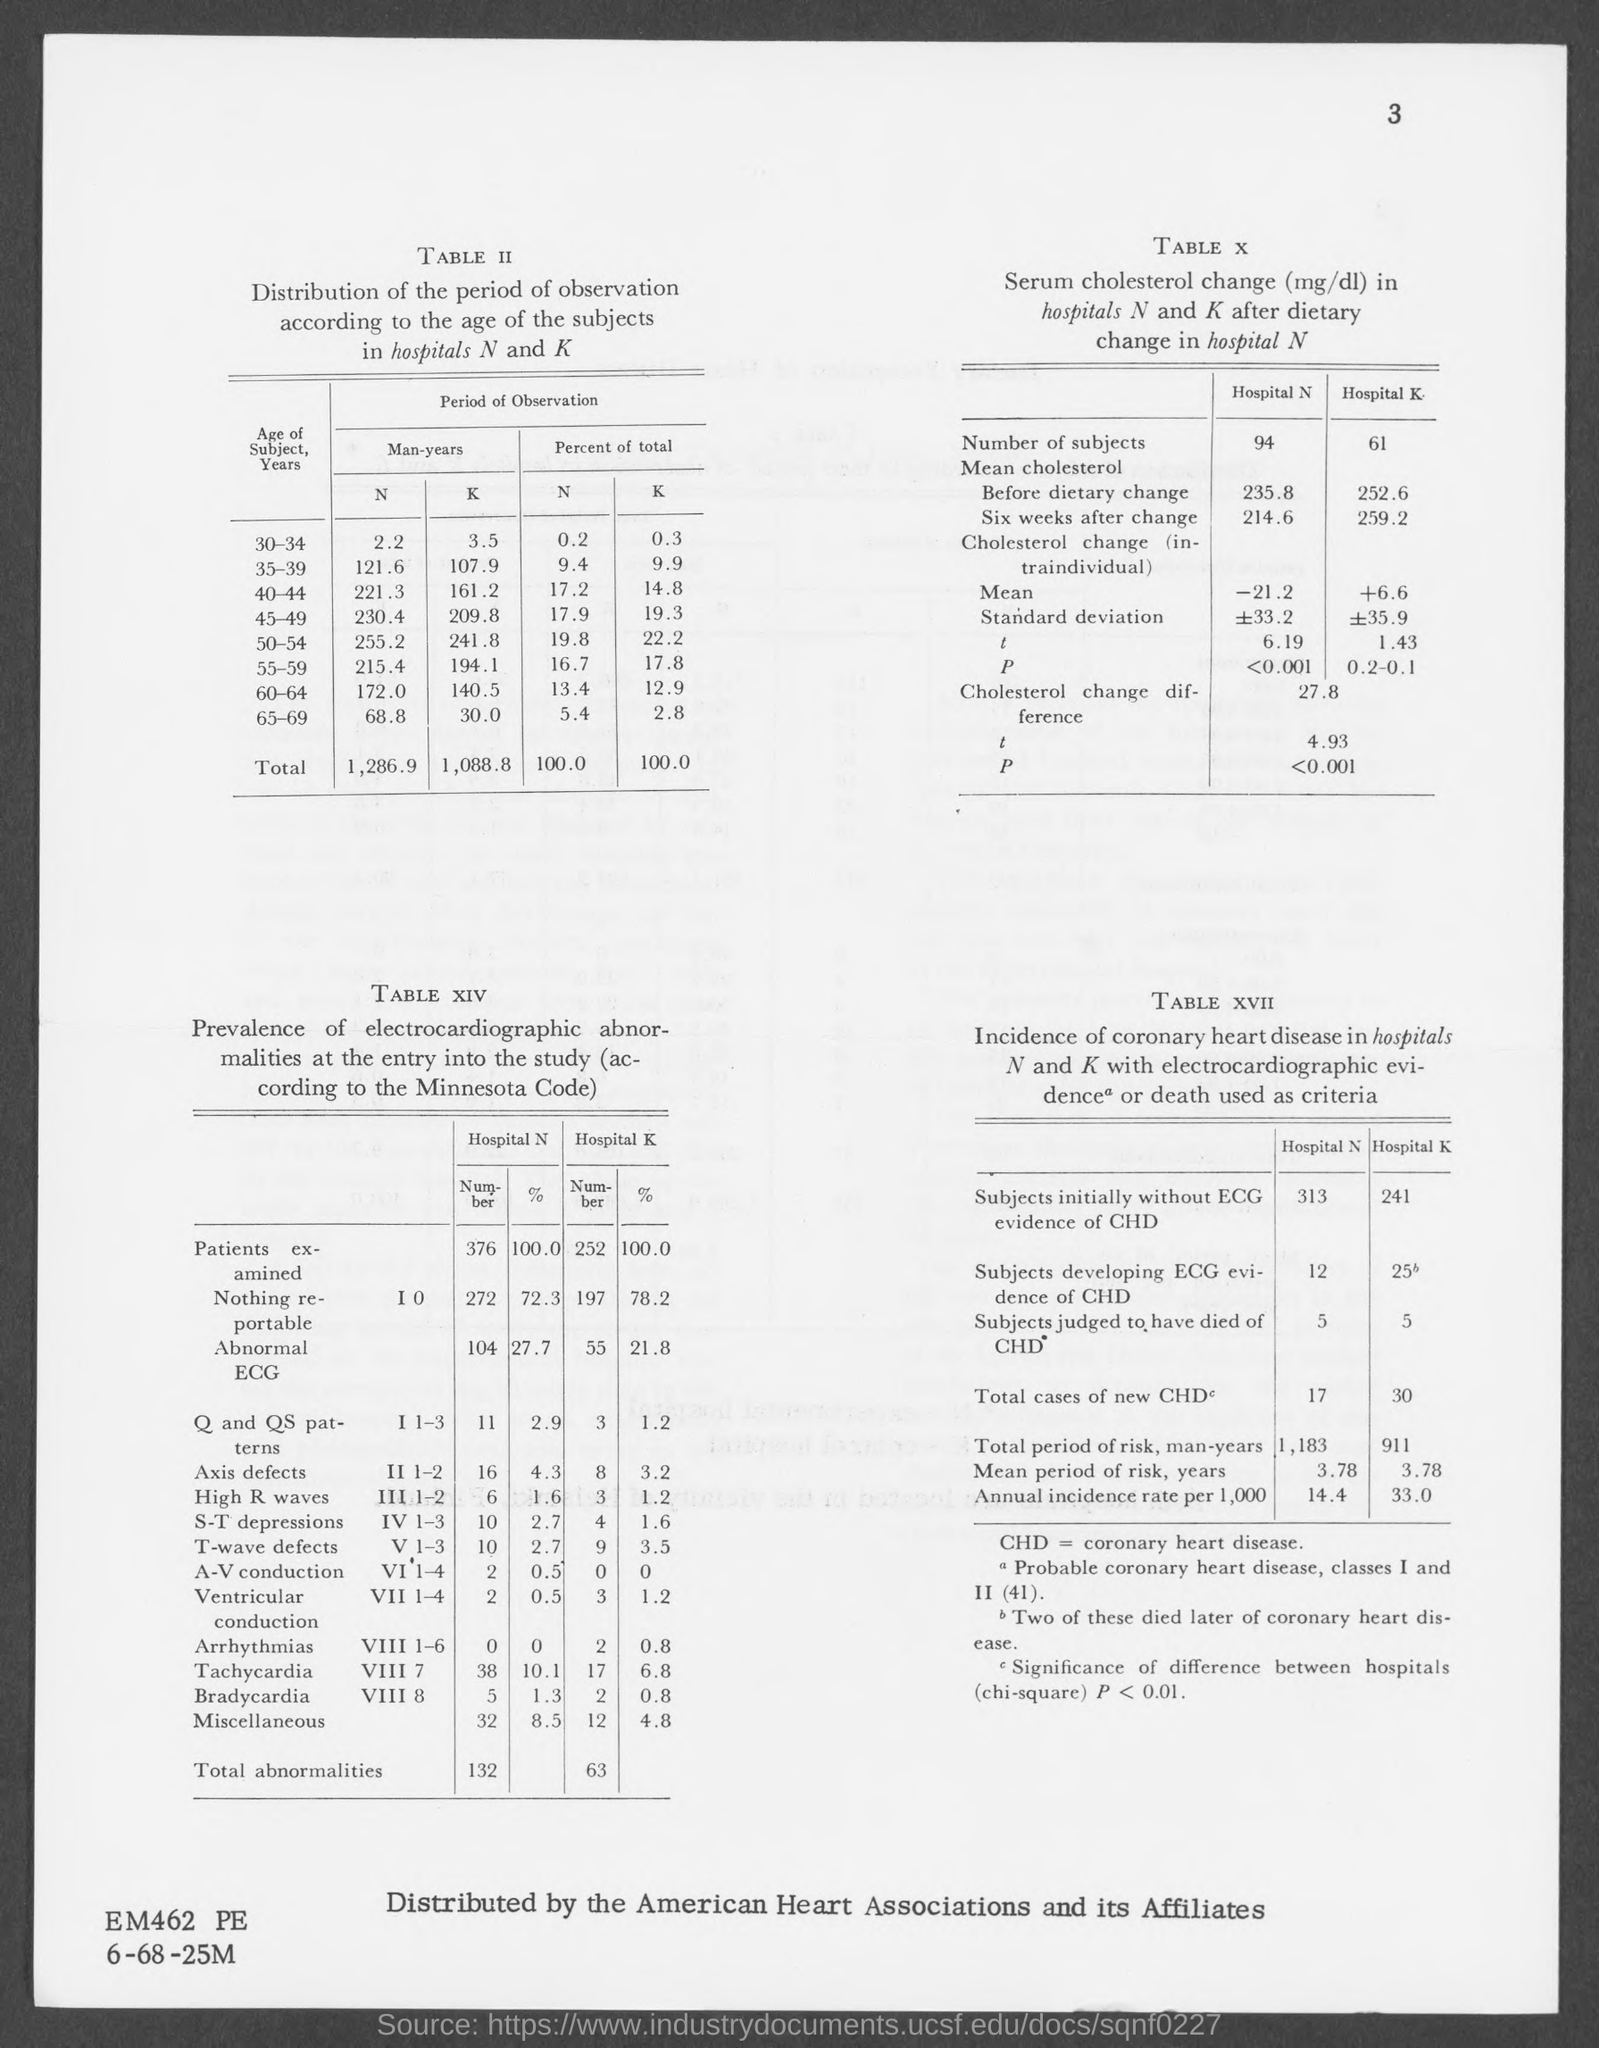What is the title of Table II?
Your response must be concise. Distribution of the period of observation according to the age of the subjects in hospitals N and K. In table II what is the total period of observation of Man-years in hospital N?
Provide a short and direct response. 1,286.9. In table II what is the total period of observation of Man-years in hospital K?
Your response must be concise. 1,088.8. What does CHD stand for?
Your response must be concise. Coronary Heart Disease. In table XVII what is the total cases of new CHD in Hospital N?
Give a very brief answer. 17. In table X what is the number of subjects in Hospital K?
Make the answer very short. 61. In table XIV how many patients were examined in hospital K?
Offer a very short reply. 252. In table XIV how many total abnormalities in hospital K?
Your answer should be very brief. 63. 